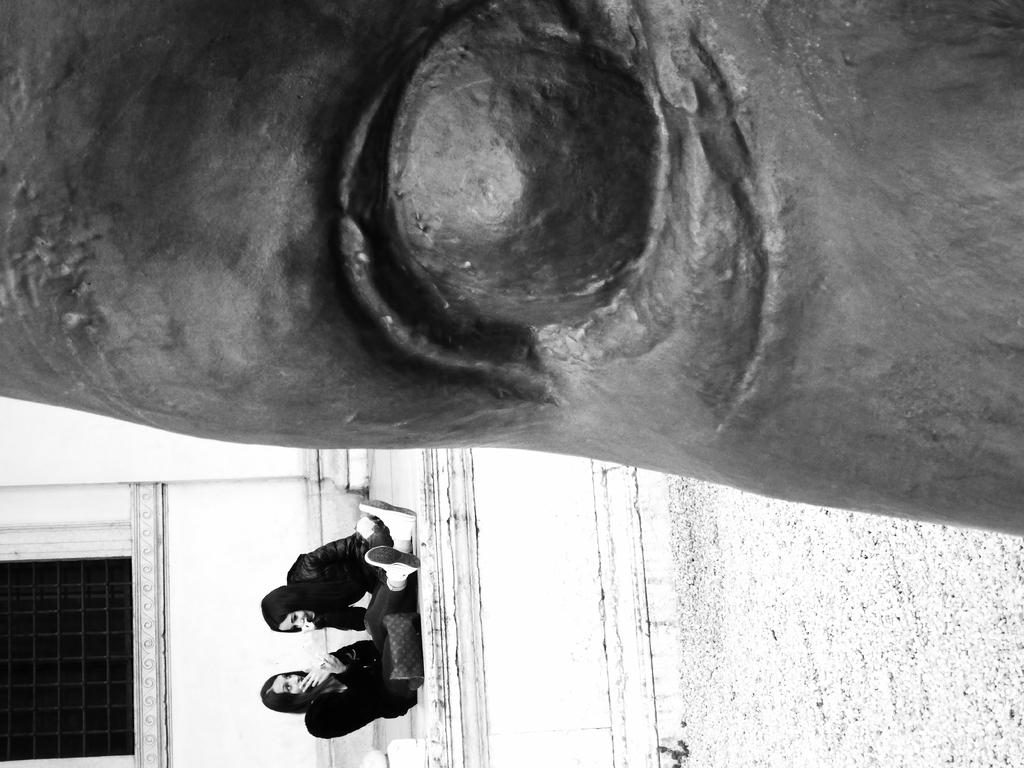What is the main subject of the image? There is a sculpture in the image. Who is present near the sculpture? Two ladies are sitting at the bottom of the sculpture. What can be seen in the background of the image? There is a wall and a window in the image. What type of donkey can be seen talking to the ladies in the image? There is no donkey present in the image, and the ladies are not engaged in any conversation. 